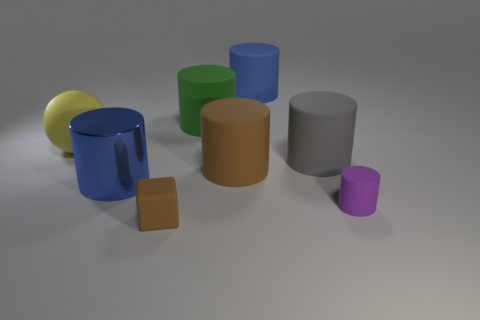Subtract 2 cylinders. How many cylinders are left? 4 Subtract all big gray rubber cylinders. How many cylinders are left? 5 Subtract all green cylinders. How many cylinders are left? 5 Subtract all brown cylinders. Subtract all green spheres. How many cylinders are left? 5 Add 2 cylinders. How many objects exist? 10 Subtract all balls. How many objects are left? 7 Add 8 tiny brown things. How many tiny brown things are left? 9 Add 6 small brown metal cylinders. How many small brown metal cylinders exist? 6 Subtract 0 yellow blocks. How many objects are left? 8 Subtract all big blue things. Subtract all big yellow spheres. How many objects are left? 5 